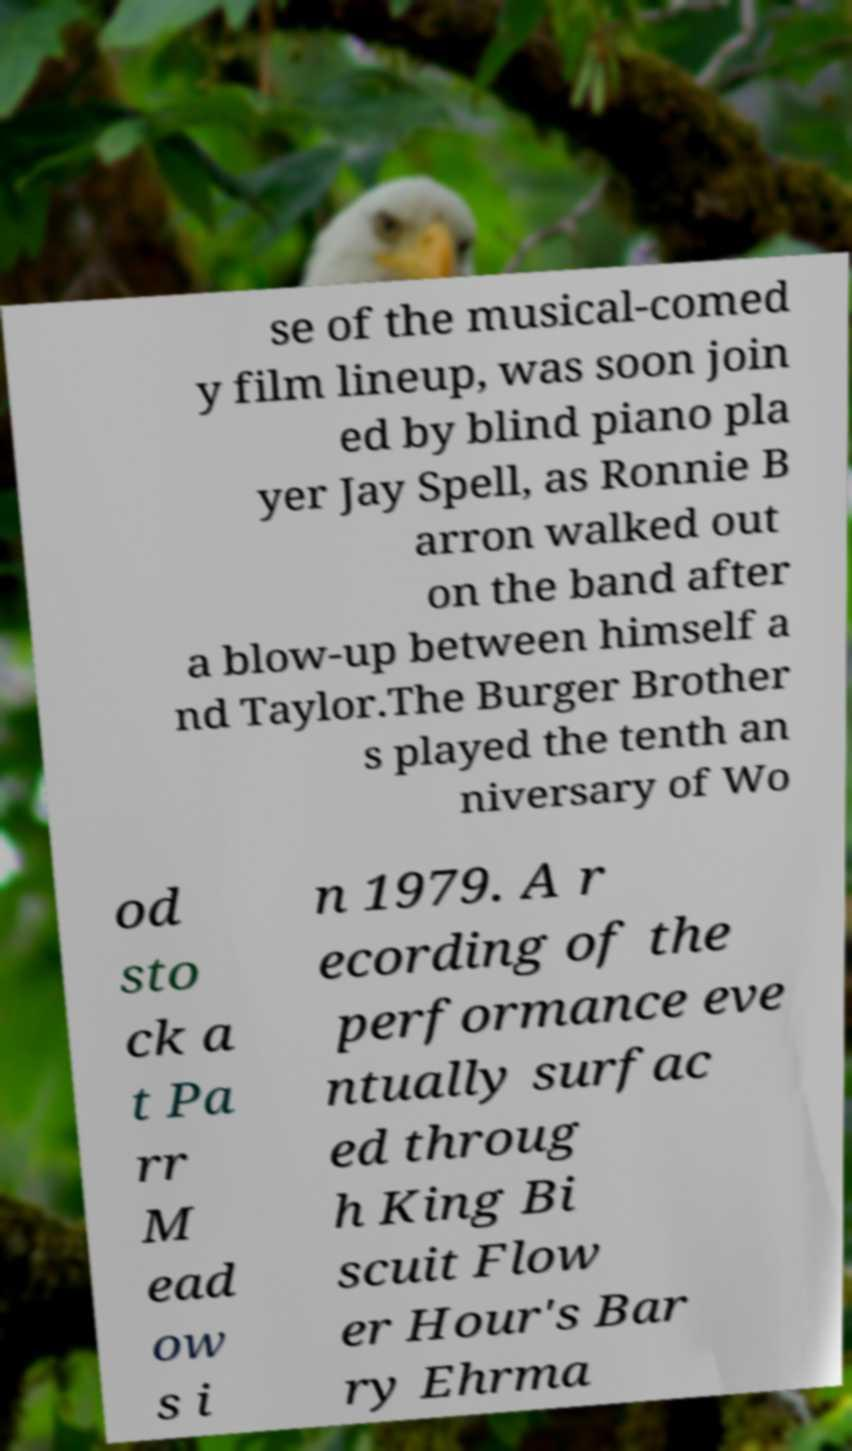Please read and relay the text visible in this image. What does it say? se of the musical-comed y film lineup, was soon join ed by blind piano pla yer Jay Spell, as Ronnie B arron walked out on the band after a blow-up between himself a nd Taylor.The Burger Brother s played the tenth an niversary of Wo od sto ck a t Pa rr M ead ow s i n 1979. A r ecording of the performance eve ntually surfac ed throug h King Bi scuit Flow er Hour's Bar ry Ehrma 